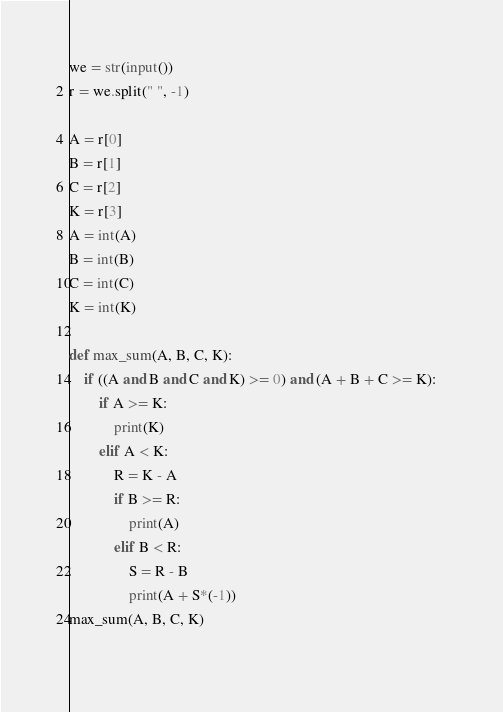<code> <loc_0><loc_0><loc_500><loc_500><_Python_>we = str(input())
r = we.split(" ", -1)

A = r[0]
B = r[1]
C = r[2]
K = r[3]
A = int(A)
B = int(B)
C = int(C)
K = int(K)

def max_sum(A, B, C, K):
	if ((A and B and C and K) >= 0) and (A + B + C >= K):   
		if A >= K:
			print(K)
		elif A < K:
			R = K - A
			if B >= R:
				print(A)
			elif B < R:
				S = R - B
				print(A + S*(-1))
max_sum(A, B, C, K)
    </code> 